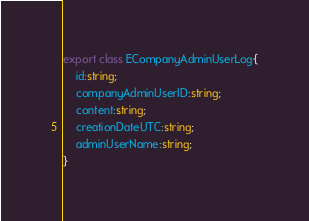<code> <loc_0><loc_0><loc_500><loc_500><_TypeScript_>
export class ECompanyAdminUserLog{
	id:string;
	companyAdminUserID:string;
	content:string;
	creationDateUTC:string;
	adminUserName:string;
}</code> 